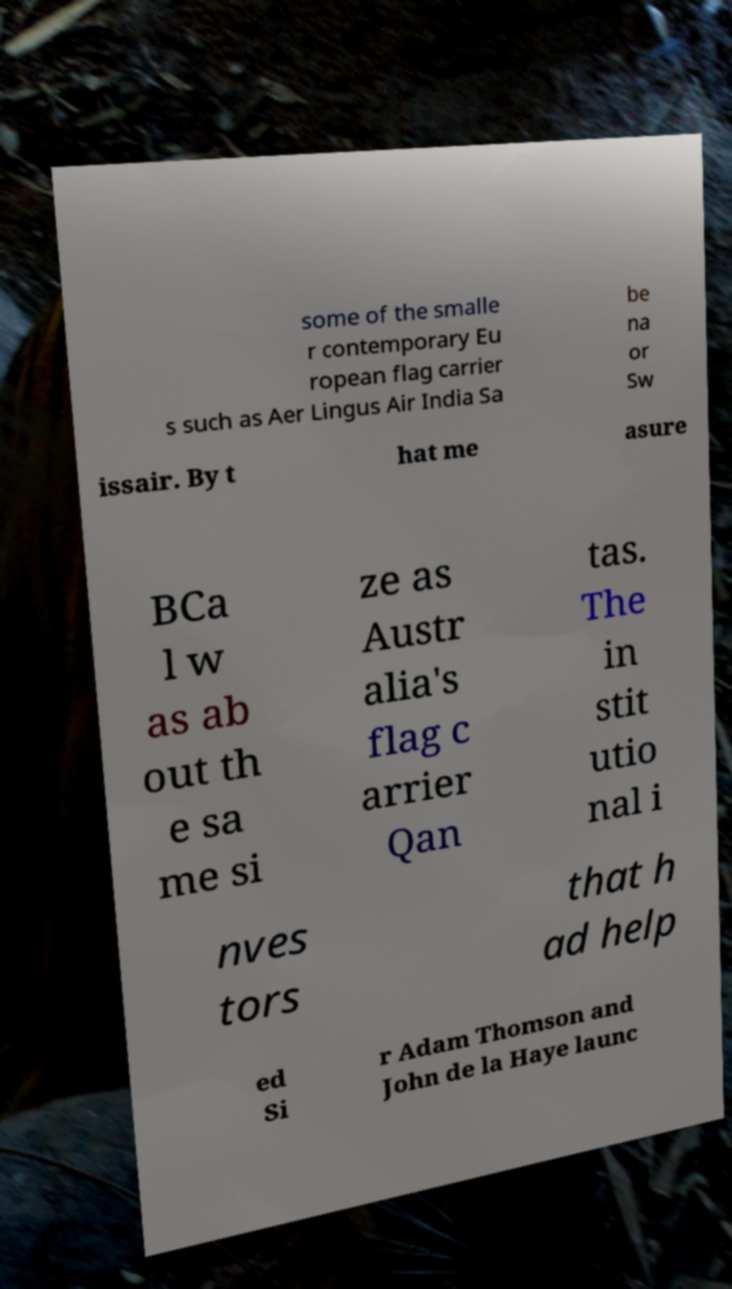Could you extract and type out the text from this image? some of the smalle r contemporary Eu ropean flag carrier s such as Aer Lingus Air India Sa be na or Sw issair. By t hat me asure BCa l w as ab out th e sa me si ze as Austr alia's flag c arrier Qan tas. The in stit utio nal i nves tors that h ad help ed Si r Adam Thomson and John de la Haye launc 